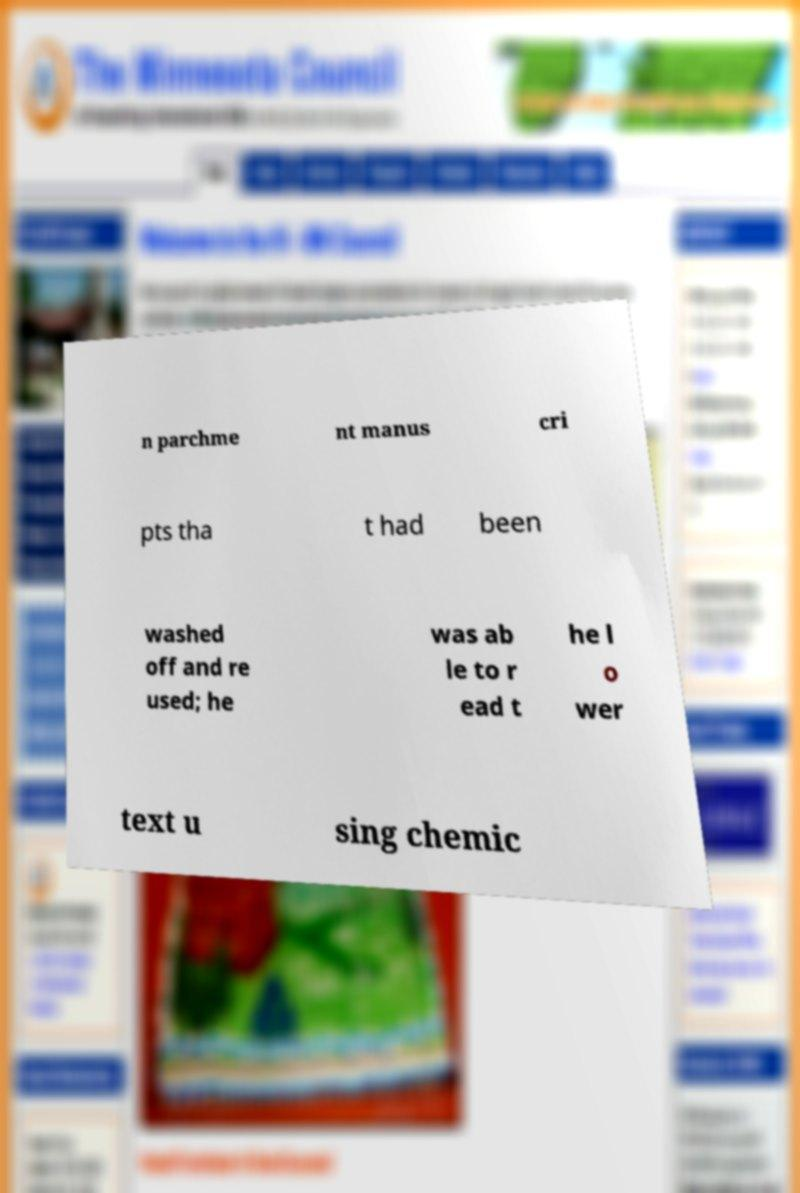Could you extract and type out the text from this image? n parchme nt manus cri pts tha t had been washed off and re used; he was ab le to r ead t he l o wer text u sing chemic 